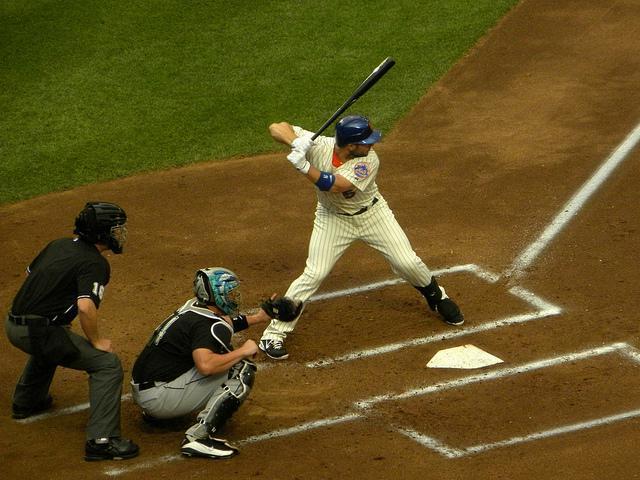How many people can you see?
Give a very brief answer. 3. How many chairs or sofas have a red pillow?
Give a very brief answer. 0. 